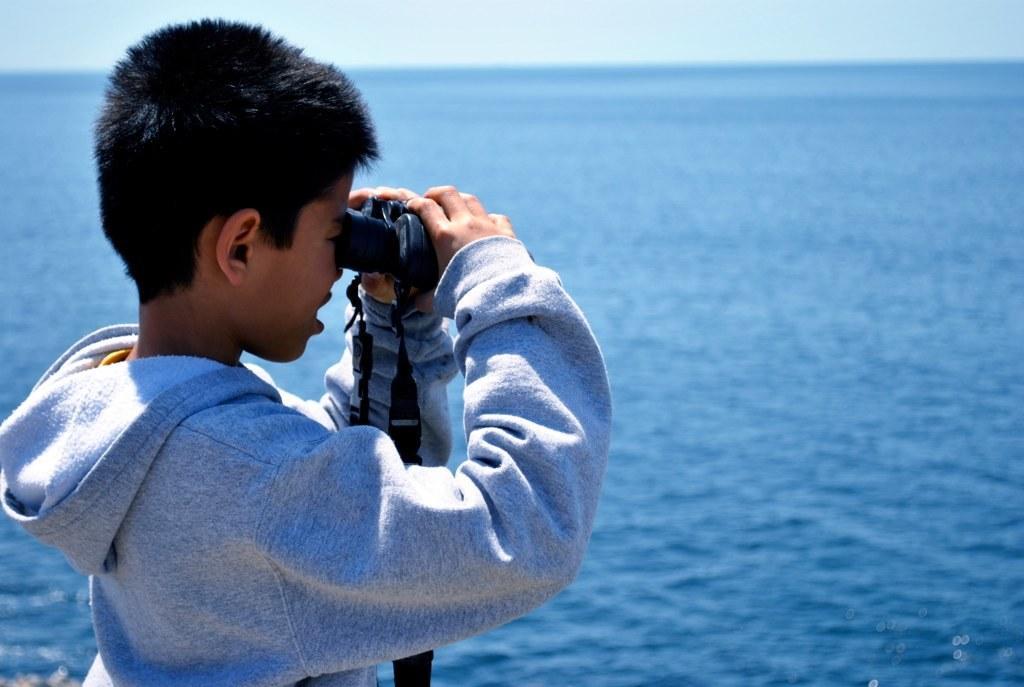In one or two sentences, can you explain what this image depicts? In this image we can see a boy holding a binocular. In the background we can see the water. Sky is also visible. 